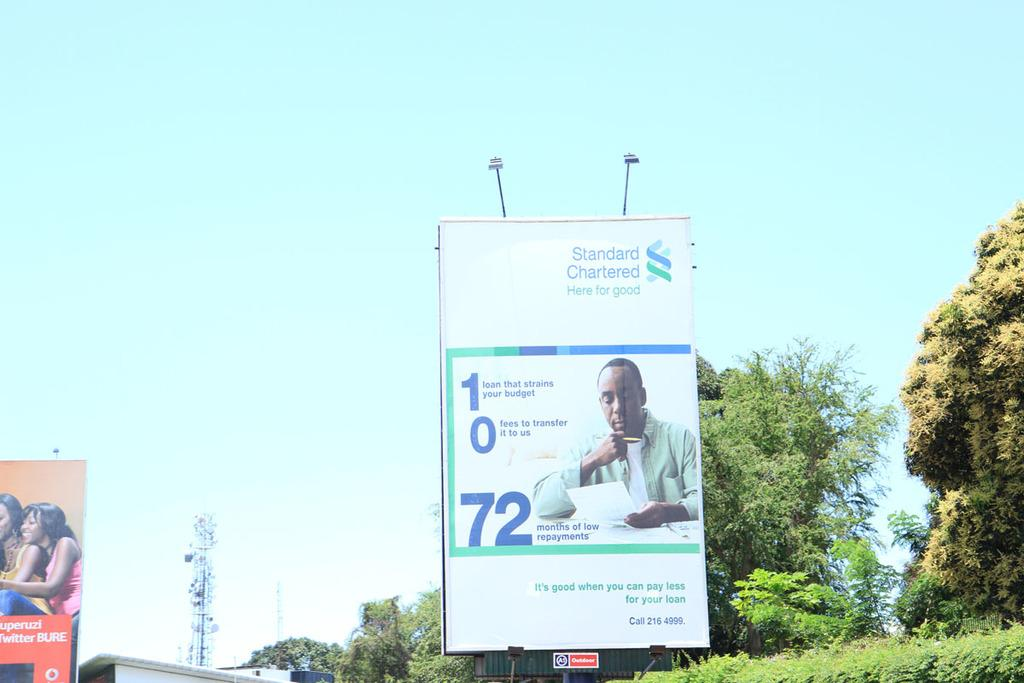<image>
Relay a brief, clear account of the picture shown. A bank billboard offers 72 months of low repayments. 